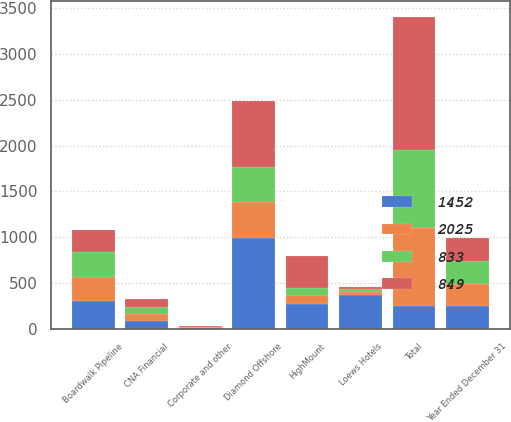Convert chart. <chart><loc_0><loc_0><loc_500><loc_500><stacked_bar_chart><ecel><fcel>Year Ended December 31<fcel>CNA Financial<fcel>Diamond Offshore<fcel>Boardwalk Pipeline<fcel>HighMount<fcel>Loews Hotels<fcel>Corporate and other<fcel>Total<nl><fcel>833<fcel>247<fcel>72<fcel>389<fcel>275<fcel>75<fcel>32<fcel>6<fcel>849<nl><fcel>1452<fcel>247<fcel>90<fcel>987<fcel>305<fcel>270<fcel>369<fcel>4<fcel>247<nl><fcel>2025<fcel>247<fcel>71<fcel>394<fcel>256<fcel>101<fcel>30<fcel>7<fcel>859<nl><fcel>849<fcel>247<fcel>98<fcel>721<fcel>247<fcel>346<fcel>30<fcel>10<fcel>1452<nl></chart> 